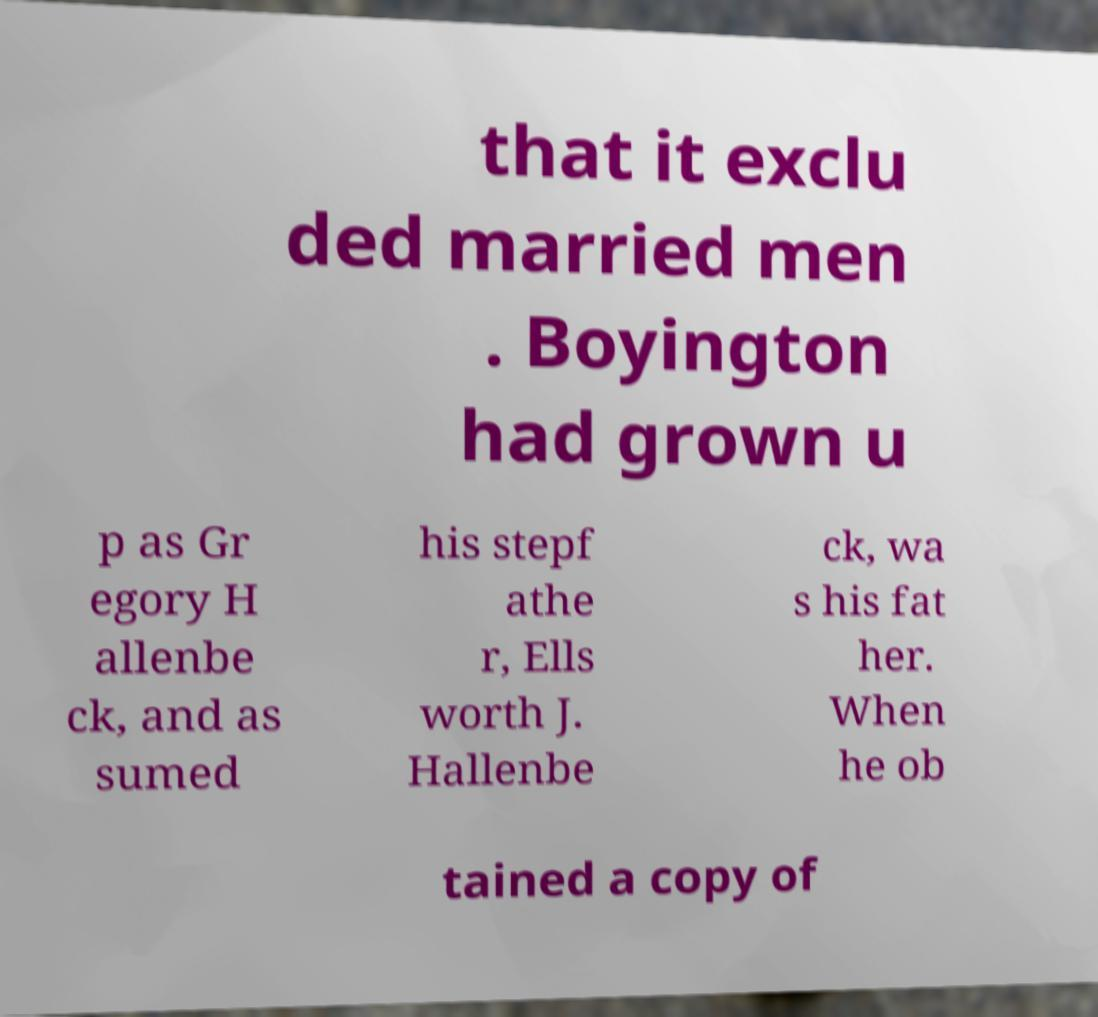For documentation purposes, I need the text within this image transcribed. Could you provide that? that it exclu ded married men . Boyington had grown u p as Gr egory H allenbe ck, and as sumed his stepf athe r, Ells worth J. Hallenbe ck, wa s his fat her. When he ob tained a copy of 